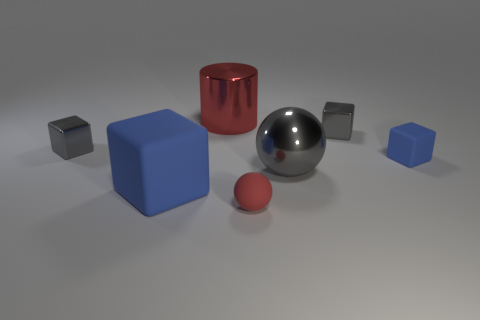Considering the placement of the objects, what might be the purpose of this arrangement? The arrangement of objects might be for a study in composition and lighting within a 3D rendering software. Each object's placement allows observation of how shapes interact with light differently, examining reflections, shadows, and material properties. It could also serve as a visual reference for understanding geometric forms and spatial relationships. 